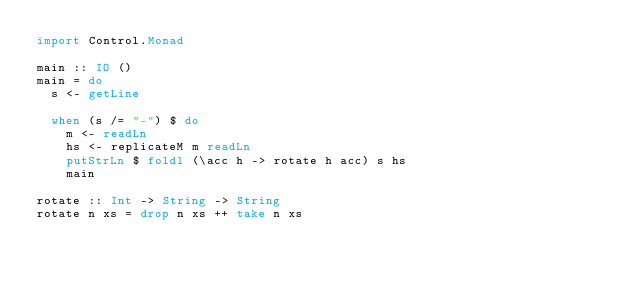<code> <loc_0><loc_0><loc_500><loc_500><_Haskell_>import Control.Monad

main :: IO ()
main = do
  s <- getLine

  when (s /= "-") $ do
    m <- readLn
    hs <- replicateM m readLn
    putStrLn $ foldl (\acc h -> rotate h acc) s hs
    main

rotate :: Int -> String -> String
rotate n xs = drop n xs ++ take n xs</code> 